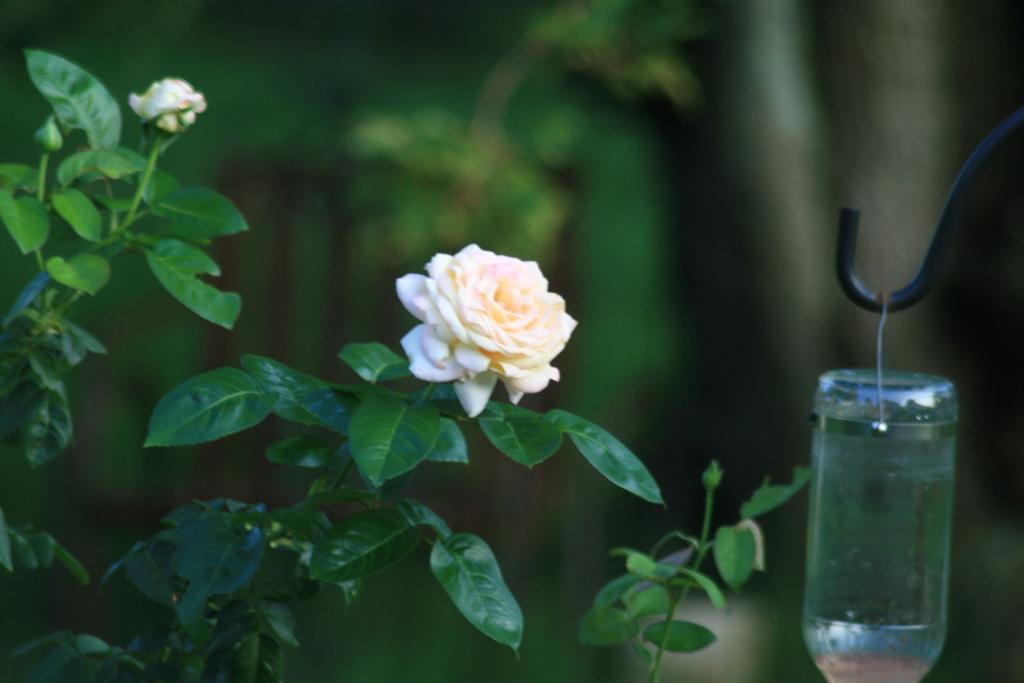Can you describe this image briefly? On the left side of the image there is a rose tree. There is a rose and a bud. On the right side there is a bottle which is hanging to the rod. 